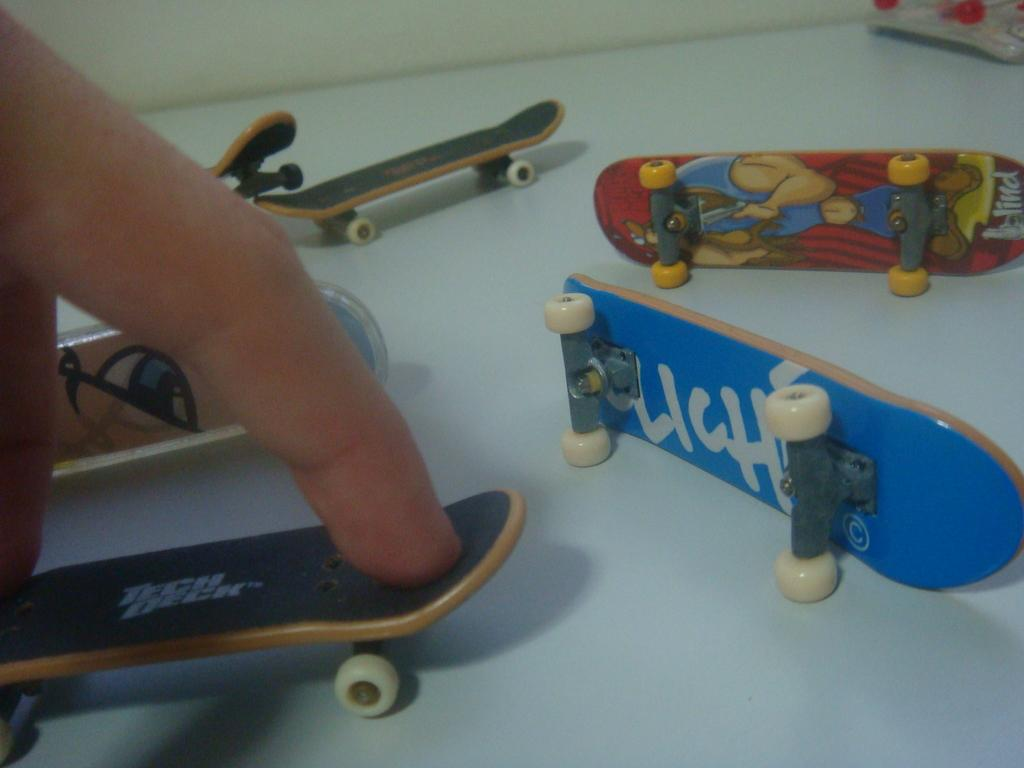What objects are on the table in the image? There are skateboards on the table. What is the person doing with one of the skateboards? A person's fingers are on a skateboard. What can be seen in the background of the image? There is a wall in the background of the image. In which direction is the earth spinning in the image? The image does not depict the earth, so it is not possible to determine the direction of its rotation. 